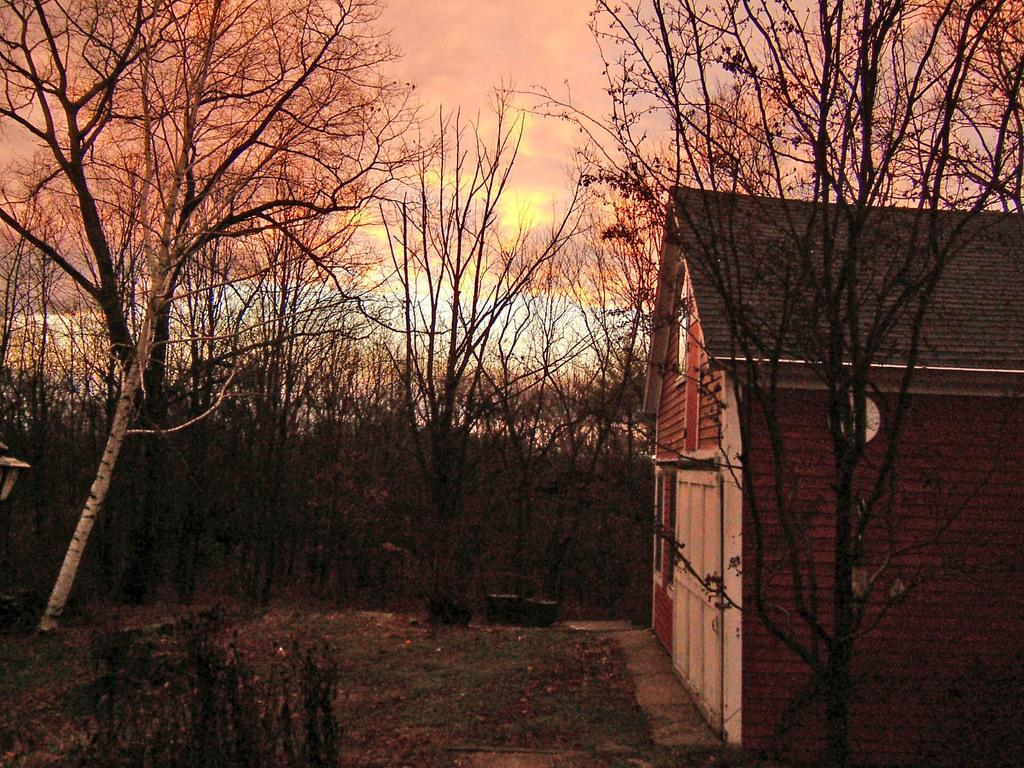What type of vegetation can be seen in the image? There are trees and plants in the image. What type of structure is visible in the image? There is a house in the image. What is visible on the ground in the image? There are objects on the ground in the image. What type of ground surface is visible in the image? There is grass in the image. What is visible in the sky in the image? The sky is visible in the image, and there are clouds in the sky. Where is the sofa located in the image? There is no sofa present in the image. What is the stomach of the tree in the image? There is no mention of a tree with a stomach in the image; trees do not have stomachs. 